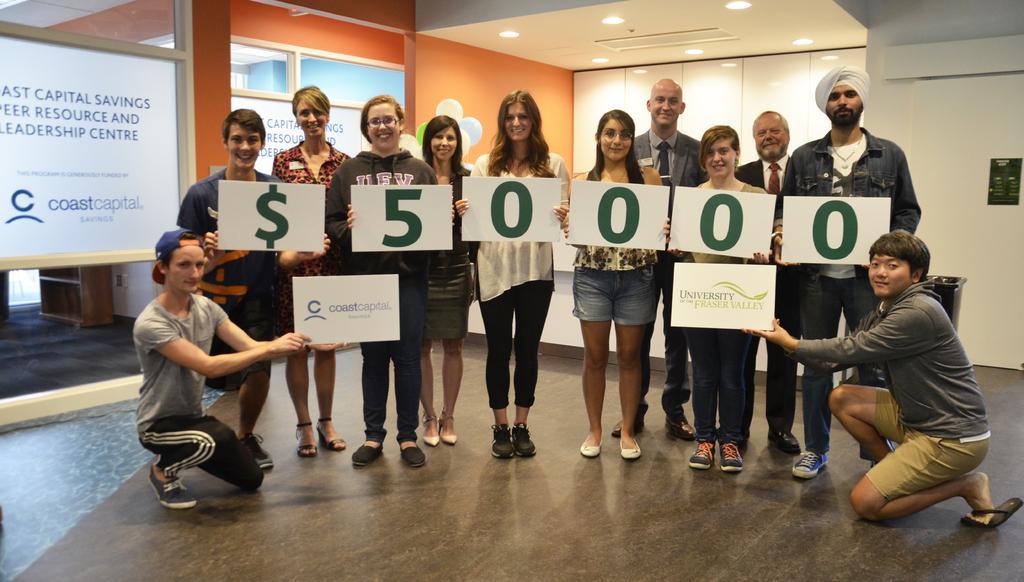In one or two sentences, can you explain what this image depicts? In this image i can see many people standing and few of them are sitting on the floor, some written text on the board, behind i can see glass windows, balloons, ceiling with the light. 